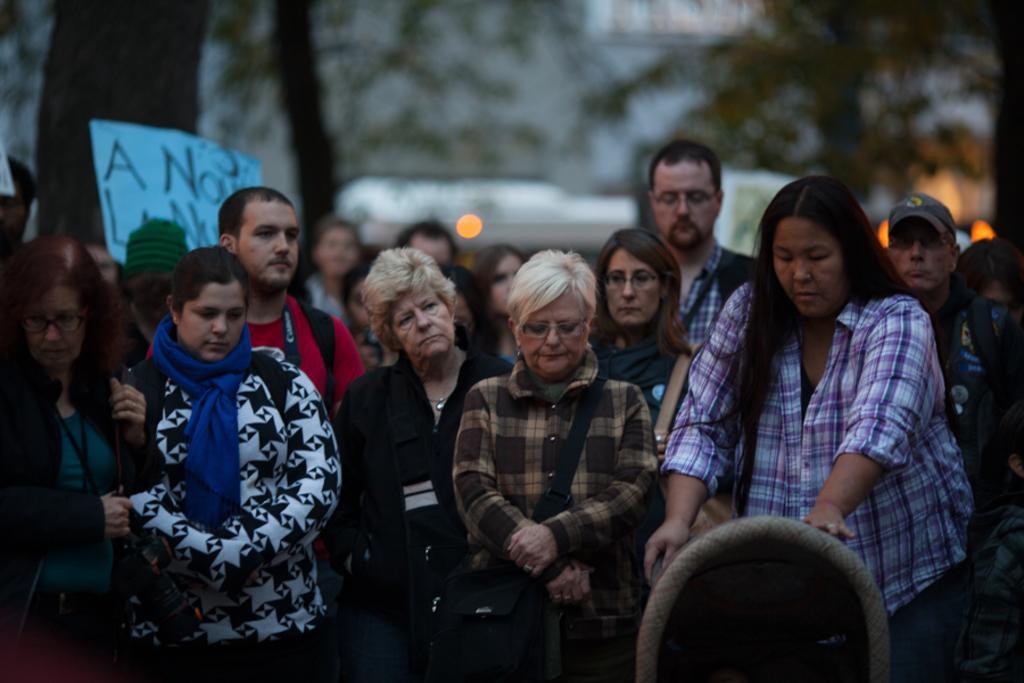How would you summarize this image in a sentence or two? In this image we can see a few people standing, among them, some people are wearing the bags, there are some trees, building and a board with some text on it. 